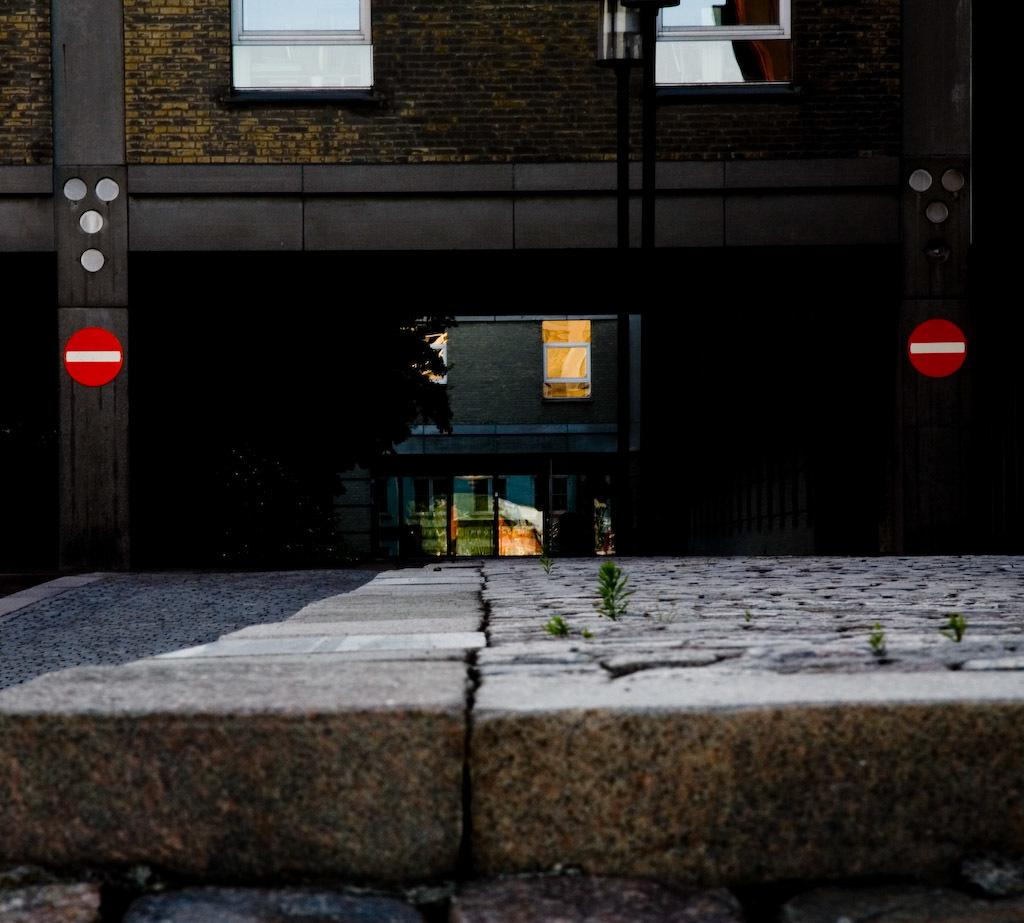What type of structures can be seen in the image? There are sign boards, buildings, and trees visible in the image. Can you describe the sign boards in the image? The sign boards in the image are likely used for advertising or providing information. What type of vegetation is present in the image? There are trees in the image. Is there a library in the image? There is no mention of a library in the provided facts, so it cannot be determined if one is present in the image. 